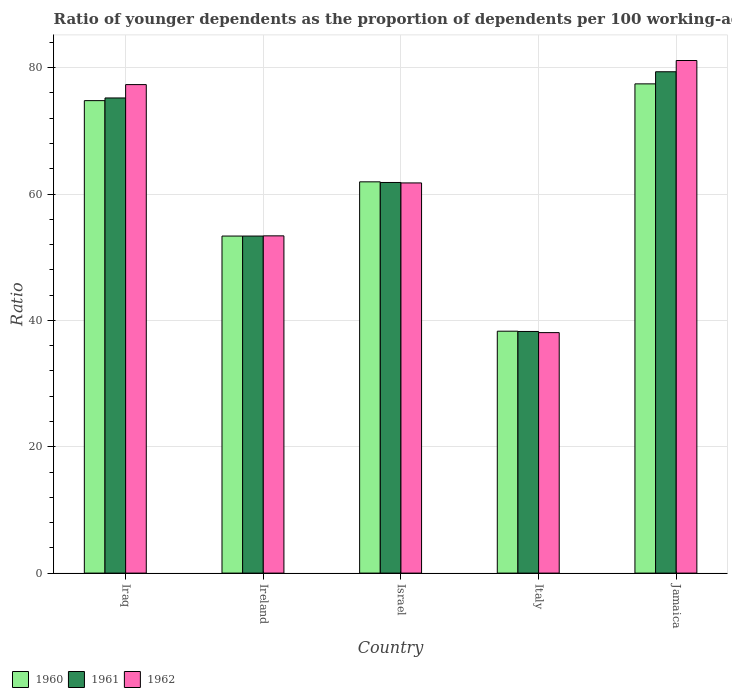How many different coloured bars are there?
Your response must be concise. 3. Are the number of bars per tick equal to the number of legend labels?
Offer a terse response. Yes. How many bars are there on the 2nd tick from the left?
Give a very brief answer. 3. What is the label of the 5th group of bars from the left?
Ensure brevity in your answer.  Jamaica. In how many cases, is the number of bars for a given country not equal to the number of legend labels?
Make the answer very short. 0. What is the age dependency ratio(young) in 1962 in Ireland?
Offer a terse response. 53.38. Across all countries, what is the maximum age dependency ratio(young) in 1960?
Make the answer very short. 77.43. Across all countries, what is the minimum age dependency ratio(young) in 1962?
Keep it short and to the point. 38.06. In which country was the age dependency ratio(young) in 1962 maximum?
Ensure brevity in your answer.  Jamaica. In which country was the age dependency ratio(young) in 1960 minimum?
Provide a short and direct response. Italy. What is the total age dependency ratio(young) in 1961 in the graph?
Keep it short and to the point. 307.97. What is the difference between the age dependency ratio(young) in 1961 in Iraq and that in Israel?
Keep it short and to the point. 13.38. What is the difference between the age dependency ratio(young) in 1960 in Israel and the age dependency ratio(young) in 1962 in Iraq?
Your answer should be compact. -15.39. What is the average age dependency ratio(young) in 1962 per country?
Your answer should be very brief. 62.33. What is the difference between the age dependency ratio(young) of/in 1962 and age dependency ratio(young) of/in 1960 in Ireland?
Ensure brevity in your answer.  0.03. What is the ratio of the age dependency ratio(young) in 1962 in Ireland to that in Jamaica?
Your response must be concise. 0.66. Is the age dependency ratio(young) in 1960 in Ireland less than that in Israel?
Provide a short and direct response. Yes. What is the difference between the highest and the second highest age dependency ratio(young) in 1960?
Ensure brevity in your answer.  12.85. What is the difference between the highest and the lowest age dependency ratio(young) in 1960?
Ensure brevity in your answer.  39.15. In how many countries, is the age dependency ratio(young) in 1960 greater than the average age dependency ratio(young) in 1960 taken over all countries?
Give a very brief answer. 3. What does the 3rd bar from the left in Italy represents?
Offer a very short reply. 1962. Is it the case that in every country, the sum of the age dependency ratio(young) in 1962 and age dependency ratio(young) in 1960 is greater than the age dependency ratio(young) in 1961?
Provide a short and direct response. Yes. How many bars are there?
Make the answer very short. 15. Are all the bars in the graph horizontal?
Keep it short and to the point. No. How many countries are there in the graph?
Make the answer very short. 5. What is the difference between two consecutive major ticks on the Y-axis?
Offer a very short reply. 20. Does the graph contain any zero values?
Give a very brief answer. No. Does the graph contain grids?
Your response must be concise. Yes. How many legend labels are there?
Make the answer very short. 3. What is the title of the graph?
Your answer should be very brief. Ratio of younger dependents as the proportion of dependents per 100 working-age population. What is the label or title of the Y-axis?
Ensure brevity in your answer.  Ratio. What is the Ratio in 1960 in Iraq?
Provide a succinct answer. 74.78. What is the Ratio of 1961 in Iraq?
Give a very brief answer. 75.2. What is the Ratio of 1962 in Iraq?
Keep it short and to the point. 77.32. What is the Ratio of 1960 in Ireland?
Your answer should be very brief. 53.35. What is the Ratio in 1961 in Ireland?
Ensure brevity in your answer.  53.35. What is the Ratio of 1962 in Ireland?
Your answer should be very brief. 53.38. What is the Ratio of 1960 in Israel?
Your response must be concise. 61.93. What is the Ratio in 1961 in Israel?
Make the answer very short. 61.83. What is the Ratio in 1962 in Israel?
Ensure brevity in your answer.  61.75. What is the Ratio of 1960 in Italy?
Offer a terse response. 38.29. What is the Ratio of 1961 in Italy?
Provide a short and direct response. 38.25. What is the Ratio in 1962 in Italy?
Provide a short and direct response. 38.06. What is the Ratio in 1960 in Jamaica?
Offer a very short reply. 77.43. What is the Ratio in 1961 in Jamaica?
Offer a terse response. 79.35. What is the Ratio of 1962 in Jamaica?
Give a very brief answer. 81.13. Across all countries, what is the maximum Ratio in 1960?
Ensure brevity in your answer.  77.43. Across all countries, what is the maximum Ratio in 1961?
Provide a short and direct response. 79.35. Across all countries, what is the maximum Ratio of 1962?
Provide a short and direct response. 81.13. Across all countries, what is the minimum Ratio of 1960?
Your answer should be very brief. 38.29. Across all countries, what is the minimum Ratio of 1961?
Provide a short and direct response. 38.25. Across all countries, what is the minimum Ratio in 1962?
Your response must be concise. 38.06. What is the total Ratio of 1960 in the graph?
Ensure brevity in your answer.  305.77. What is the total Ratio in 1961 in the graph?
Your response must be concise. 307.97. What is the total Ratio in 1962 in the graph?
Offer a very short reply. 311.64. What is the difference between the Ratio of 1960 in Iraq and that in Ireland?
Give a very brief answer. 21.43. What is the difference between the Ratio of 1961 in Iraq and that in Ireland?
Make the answer very short. 21.86. What is the difference between the Ratio in 1962 in Iraq and that in Ireland?
Offer a very short reply. 23.94. What is the difference between the Ratio of 1960 in Iraq and that in Israel?
Provide a succinct answer. 12.85. What is the difference between the Ratio of 1961 in Iraq and that in Israel?
Ensure brevity in your answer.  13.38. What is the difference between the Ratio of 1962 in Iraq and that in Israel?
Make the answer very short. 15.56. What is the difference between the Ratio in 1960 in Iraq and that in Italy?
Keep it short and to the point. 36.49. What is the difference between the Ratio in 1961 in Iraq and that in Italy?
Offer a very short reply. 36.96. What is the difference between the Ratio of 1962 in Iraq and that in Italy?
Give a very brief answer. 39.25. What is the difference between the Ratio of 1960 in Iraq and that in Jamaica?
Provide a succinct answer. -2.65. What is the difference between the Ratio of 1961 in Iraq and that in Jamaica?
Make the answer very short. -4.15. What is the difference between the Ratio in 1962 in Iraq and that in Jamaica?
Provide a succinct answer. -3.81. What is the difference between the Ratio of 1960 in Ireland and that in Israel?
Make the answer very short. -8.58. What is the difference between the Ratio of 1961 in Ireland and that in Israel?
Offer a terse response. -8.48. What is the difference between the Ratio in 1962 in Ireland and that in Israel?
Your answer should be compact. -8.38. What is the difference between the Ratio in 1960 in Ireland and that in Italy?
Offer a terse response. 15.06. What is the difference between the Ratio in 1961 in Ireland and that in Italy?
Your response must be concise. 15.1. What is the difference between the Ratio of 1962 in Ireland and that in Italy?
Your answer should be compact. 15.32. What is the difference between the Ratio of 1960 in Ireland and that in Jamaica?
Provide a succinct answer. -24.09. What is the difference between the Ratio in 1961 in Ireland and that in Jamaica?
Keep it short and to the point. -26. What is the difference between the Ratio in 1962 in Ireland and that in Jamaica?
Your response must be concise. -27.75. What is the difference between the Ratio of 1960 in Israel and that in Italy?
Your answer should be compact. 23.64. What is the difference between the Ratio of 1961 in Israel and that in Italy?
Provide a short and direct response. 23.58. What is the difference between the Ratio of 1962 in Israel and that in Italy?
Offer a terse response. 23.69. What is the difference between the Ratio in 1960 in Israel and that in Jamaica?
Provide a succinct answer. -15.5. What is the difference between the Ratio of 1961 in Israel and that in Jamaica?
Make the answer very short. -17.52. What is the difference between the Ratio of 1962 in Israel and that in Jamaica?
Ensure brevity in your answer.  -19.38. What is the difference between the Ratio of 1960 in Italy and that in Jamaica?
Ensure brevity in your answer.  -39.15. What is the difference between the Ratio in 1961 in Italy and that in Jamaica?
Provide a succinct answer. -41.1. What is the difference between the Ratio of 1962 in Italy and that in Jamaica?
Provide a succinct answer. -43.07. What is the difference between the Ratio in 1960 in Iraq and the Ratio in 1961 in Ireland?
Your answer should be compact. 21.43. What is the difference between the Ratio in 1960 in Iraq and the Ratio in 1962 in Ireland?
Your response must be concise. 21.4. What is the difference between the Ratio of 1961 in Iraq and the Ratio of 1962 in Ireland?
Offer a terse response. 21.82. What is the difference between the Ratio in 1960 in Iraq and the Ratio in 1961 in Israel?
Your answer should be compact. 12.95. What is the difference between the Ratio of 1960 in Iraq and the Ratio of 1962 in Israel?
Your answer should be compact. 13.02. What is the difference between the Ratio in 1961 in Iraq and the Ratio in 1962 in Israel?
Offer a terse response. 13.45. What is the difference between the Ratio in 1960 in Iraq and the Ratio in 1961 in Italy?
Provide a succinct answer. 36.53. What is the difference between the Ratio in 1960 in Iraq and the Ratio in 1962 in Italy?
Your answer should be very brief. 36.72. What is the difference between the Ratio in 1961 in Iraq and the Ratio in 1962 in Italy?
Your response must be concise. 37.14. What is the difference between the Ratio in 1960 in Iraq and the Ratio in 1961 in Jamaica?
Offer a very short reply. -4.57. What is the difference between the Ratio of 1960 in Iraq and the Ratio of 1962 in Jamaica?
Your answer should be very brief. -6.35. What is the difference between the Ratio of 1961 in Iraq and the Ratio of 1962 in Jamaica?
Keep it short and to the point. -5.93. What is the difference between the Ratio of 1960 in Ireland and the Ratio of 1961 in Israel?
Provide a short and direct response. -8.48. What is the difference between the Ratio of 1960 in Ireland and the Ratio of 1962 in Israel?
Ensure brevity in your answer.  -8.41. What is the difference between the Ratio of 1961 in Ireland and the Ratio of 1962 in Israel?
Your answer should be very brief. -8.41. What is the difference between the Ratio of 1960 in Ireland and the Ratio of 1961 in Italy?
Keep it short and to the point. 15.1. What is the difference between the Ratio in 1960 in Ireland and the Ratio in 1962 in Italy?
Give a very brief answer. 15.28. What is the difference between the Ratio of 1961 in Ireland and the Ratio of 1962 in Italy?
Give a very brief answer. 15.28. What is the difference between the Ratio in 1960 in Ireland and the Ratio in 1961 in Jamaica?
Give a very brief answer. -26. What is the difference between the Ratio of 1960 in Ireland and the Ratio of 1962 in Jamaica?
Your response must be concise. -27.79. What is the difference between the Ratio of 1961 in Ireland and the Ratio of 1962 in Jamaica?
Provide a succinct answer. -27.79. What is the difference between the Ratio in 1960 in Israel and the Ratio in 1961 in Italy?
Make the answer very short. 23.68. What is the difference between the Ratio in 1960 in Israel and the Ratio in 1962 in Italy?
Ensure brevity in your answer.  23.87. What is the difference between the Ratio in 1961 in Israel and the Ratio in 1962 in Italy?
Your answer should be very brief. 23.76. What is the difference between the Ratio in 1960 in Israel and the Ratio in 1961 in Jamaica?
Give a very brief answer. -17.42. What is the difference between the Ratio of 1960 in Israel and the Ratio of 1962 in Jamaica?
Your answer should be compact. -19.2. What is the difference between the Ratio of 1961 in Israel and the Ratio of 1962 in Jamaica?
Give a very brief answer. -19.3. What is the difference between the Ratio in 1960 in Italy and the Ratio in 1961 in Jamaica?
Keep it short and to the point. -41.06. What is the difference between the Ratio in 1960 in Italy and the Ratio in 1962 in Jamaica?
Offer a terse response. -42.84. What is the difference between the Ratio in 1961 in Italy and the Ratio in 1962 in Jamaica?
Ensure brevity in your answer.  -42.89. What is the average Ratio in 1960 per country?
Give a very brief answer. 61.15. What is the average Ratio of 1961 per country?
Your answer should be very brief. 61.59. What is the average Ratio in 1962 per country?
Provide a succinct answer. 62.33. What is the difference between the Ratio in 1960 and Ratio in 1961 in Iraq?
Make the answer very short. -0.42. What is the difference between the Ratio in 1960 and Ratio in 1962 in Iraq?
Your answer should be very brief. -2.54. What is the difference between the Ratio of 1961 and Ratio of 1962 in Iraq?
Ensure brevity in your answer.  -2.11. What is the difference between the Ratio in 1960 and Ratio in 1961 in Ireland?
Your response must be concise. -0. What is the difference between the Ratio in 1960 and Ratio in 1962 in Ireland?
Provide a short and direct response. -0.03. What is the difference between the Ratio of 1961 and Ratio of 1962 in Ireland?
Offer a very short reply. -0.03. What is the difference between the Ratio of 1960 and Ratio of 1961 in Israel?
Your answer should be very brief. 0.1. What is the difference between the Ratio in 1960 and Ratio in 1962 in Israel?
Give a very brief answer. 0.17. What is the difference between the Ratio in 1961 and Ratio in 1962 in Israel?
Provide a succinct answer. 0.07. What is the difference between the Ratio of 1960 and Ratio of 1961 in Italy?
Give a very brief answer. 0.04. What is the difference between the Ratio in 1960 and Ratio in 1962 in Italy?
Offer a very short reply. 0.22. What is the difference between the Ratio of 1961 and Ratio of 1962 in Italy?
Ensure brevity in your answer.  0.18. What is the difference between the Ratio in 1960 and Ratio in 1961 in Jamaica?
Your answer should be compact. -1.92. What is the difference between the Ratio in 1960 and Ratio in 1962 in Jamaica?
Your answer should be compact. -3.7. What is the difference between the Ratio of 1961 and Ratio of 1962 in Jamaica?
Make the answer very short. -1.78. What is the ratio of the Ratio of 1960 in Iraq to that in Ireland?
Offer a terse response. 1.4. What is the ratio of the Ratio in 1961 in Iraq to that in Ireland?
Your response must be concise. 1.41. What is the ratio of the Ratio of 1962 in Iraq to that in Ireland?
Provide a short and direct response. 1.45. What is the ratio of the Ratio of 1960 in Iraq to that in Israel?
Make the answer very short. 1.21. What is the ratio of the Ratio of 1961 in Iraq to that in Israel?
Your response must be concise. 1.22. What is the ratio of the Ratio in 1962 in Iraq to that in Israel?
Your answer should be very brief. 1.25. What is the ratio of the Ratio of 1960 in Iraq to that in Italy?
Your answer should be compact. 1.95. What is the ratio of the Ratio in 1961 in Iraq to that in Italy?
Make the answer very short. 1.97. What is the ratio of the Ratio of 1962 in Iraq to that in Italy?
Your answer should be compact. 2.03. What is the ratio of the Ratio of 1960 in Iraq to that in Jamaica?
Offer a very short reply. 0.97. What is the ratio of the Ratio of 1961 in Iraq to that in Jamaica?
Ensure brevity in your answer.  0.95. What is the ratio of the Ratio of 1962 in Iraq to that in Jamaica?
Provide a succinct answer. 0.95. What is the ratio of the Ratio in 1960 in Ireland to that in Israel?
Your response must be concise. 0.86. What is the ratio of the Ratio in 1961 in Ireland to that in Israel?
Provide a short and direct response. 0.86. What is the ratio of the Ratio of 1962 in Ireland to that in Israel?
Offer a very short reply. 0.86. What is the ratio of the Ratio of 1960 in Ireland to that in Italy?
Give a very brief answer. 1.39. What is the ratio of the Ratio in 1961 in Ireland to that in Italy?
Your answer should be very brief. 1.39. What is the ratio of the Ratio of 1962 in Ireland to that in Italy?
Provide a short and direct response. 1.4. What is the ratio of the Ratio in 1960 in Ireland to that in Jamaica?
Make the answer very short. 0.69. What is the ratio of the Ratio in 1961 in Ireland to that in Jamaica?
Your answer should be very brief. 0.67. What is the ratio of the Ratio in 1962 in Ireland to that in Jamaica?
Ensure brevity in your answer.  0.66. What is the ratio of the Ratio in 1960 in Israel to that in Italy?
Your response must be concise. 1.62. What is the ratio of the Ratio of 1961 in Israel to that in Italy?
Provide a succinct answer. 1.62. What is the ratio of the Ratio in 1962 in Israel to that in Italy?
Give a very brief answer. 1.62. What is the ratio of the Ratio of 1960 in Israel to that in Jamaica?
Provide a short and direct response. 0.8. What is the ratio of the Ratio of 1961 in Israel to that in Jamaica?
Give a very brief answer. 0.78. What is the ratio of the Ratio in 1962 in Israel to that in Jamaica?
Your response must be concise. 0.76. What is the ratio of the Ratio in 1960 in Italy to that in Jamaica?
Make the answer very short. 0.49. What is the ratio of the Ratio of 1961 in Italy to that in Jamaica?
Your response must be concise. 0.48. What is the ratio of the Ratio of 1962 in Italy to that in Jamaica?
Your response must be concise. 0.47. What is the difference between the highest and the second highest Ratio of 1960?
Give a very brief answer. 2.65. What is the difference between the highest and the second highest Ratio in 1961?
Offer a very short reply. 4.15. What is the difference between the highest and the second highest Ratio in 1962?
Give a very brief answer. 3.81. What is the difference between the highest and the lowest Ratio in 1960?
Provide a succinct answer. 39.15. What is the difference between the highest and the lowest Ratio in 1961?
Make the answer very short. 41.1. What is the difference between the highest and the lowest Ratio of 1962?
Provide a short and direct response. 43.07. 